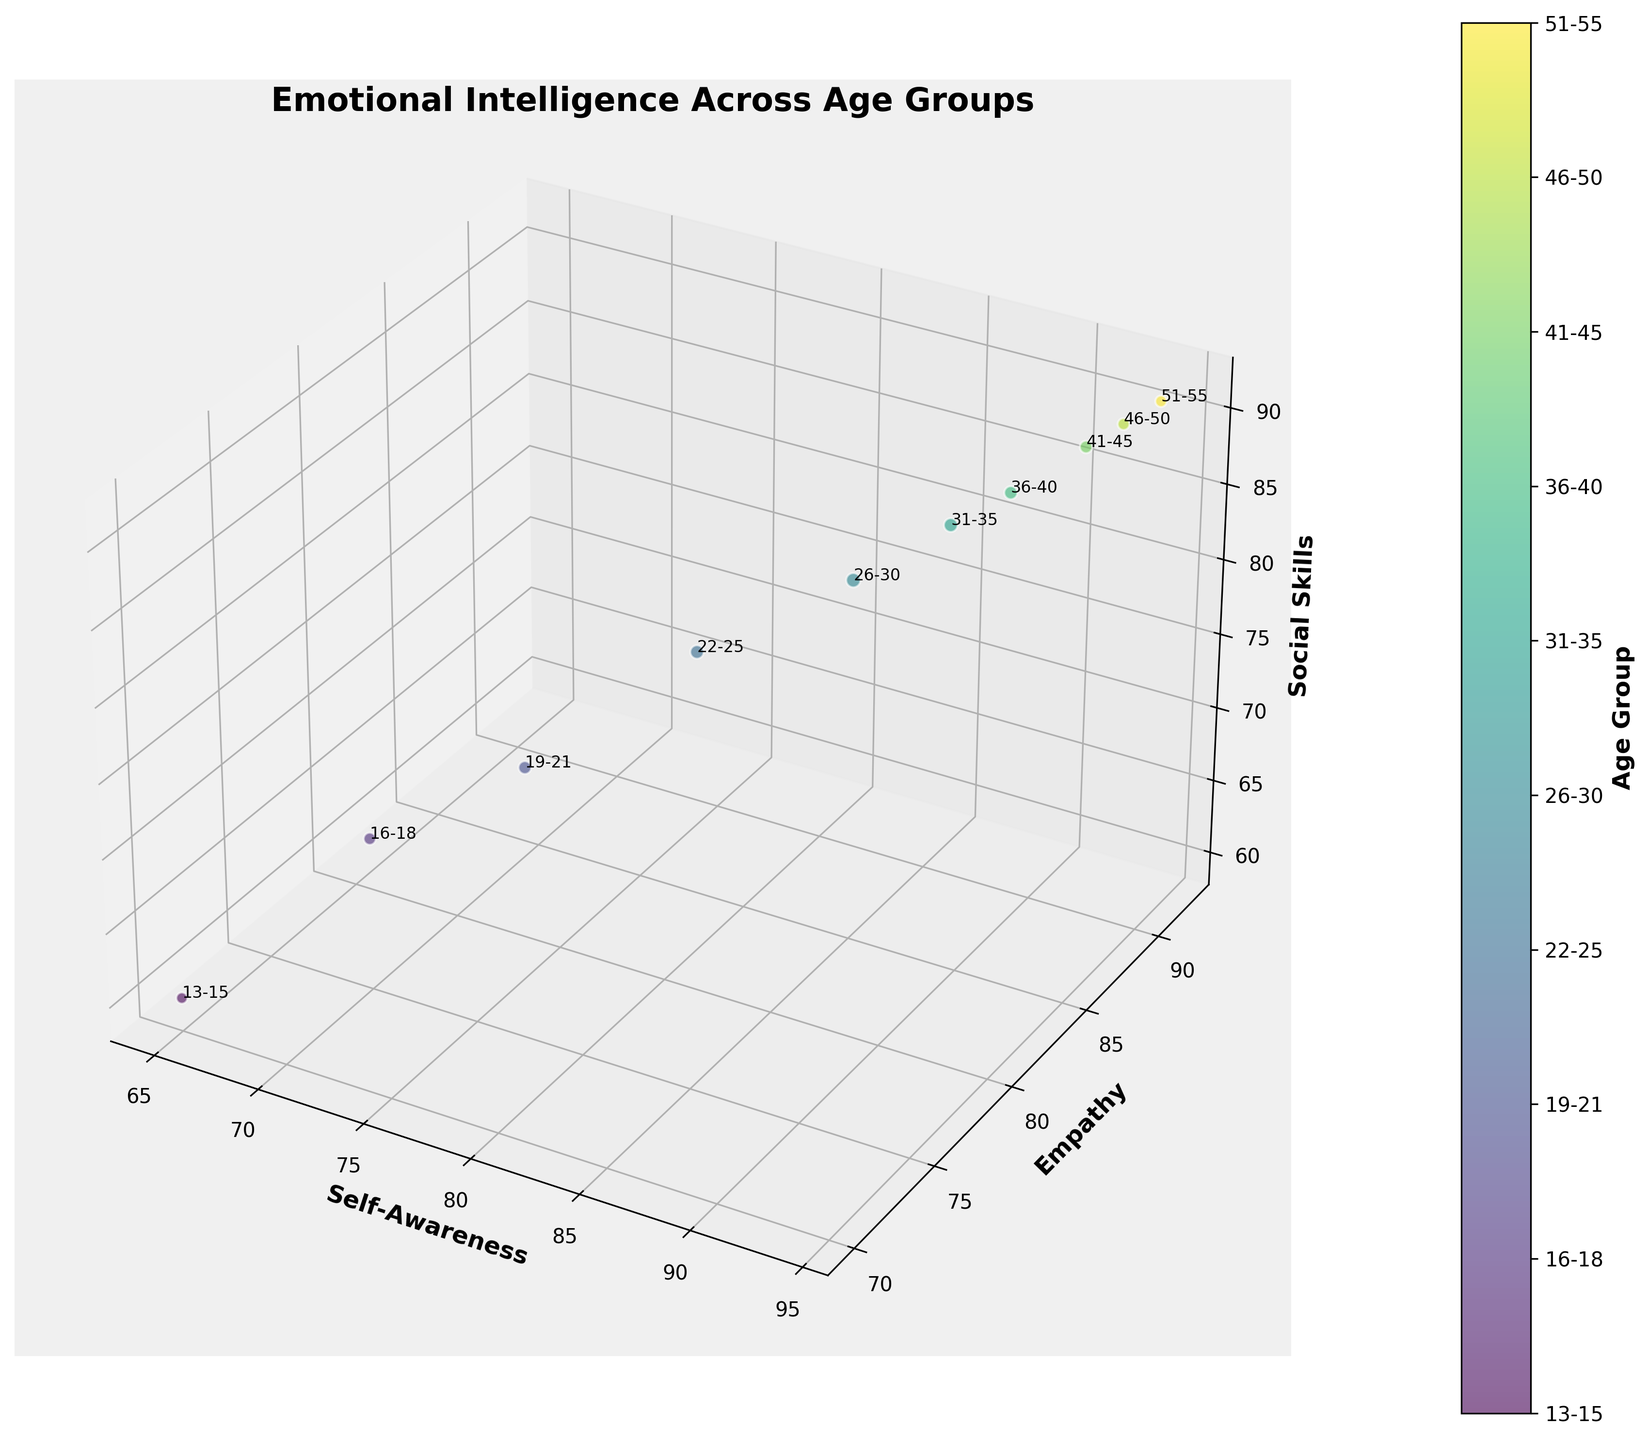what does the title of the figure indicate? The title of the figure is "Emotional Intelligence Across Age Groups". It suggests that the figure is about the variation of emotional intelligence metrics (self-awareness, empathy, and social skills) across different age groups.
Answer: Emotional Intelligence Across Age Groups How many age groups are there in the figure? By looking at the number of bubbles in the figure and the color bar labels, we can count the distinct age groups.
Answer: 10 What is the label on the x-axis? The label on the x-axis represents one of the emotional intelligence metrics being measured.
Answer: Self-Awareness Which age group has the largest bubble size? The size of the bubbles represents the sample size for each age group. The largest bubble is for the age group with the highest sample size.
Answer: 26-30 What is the average value of Self-Awareness for age groups 22-25 and 26-30? The self-awareness values for age groups 22-25 and 26-30 are 80 and 85, respectively. The average is calculated as (80 + 85) / 2.
Answer: 82.5 Does the empathy score generally increase or decrease with age? By observing the y-axis values for different age groups, we can see that the empathy score generally increases as the age group gets older.
Answer: Increase Which two age groups have the closest values in empathy? To find the closest empathy values, we need to compare the scores of all age groups and identify the two that are the most similar. Comparing all pairs, the closest values are those of age groups 41-45 and 46-50 (90 and 91).
Answer: 41-45 and 46-50 Does the 51-55 age group have higher, lower, or similar social skills scores compared to the 36-40 age group? By comparing the z-axis values for the age groups 51-55 and 36-40, we see 51-55 has a social skills score of 91 and 36-40 has 87, indicating a higher value for 51-55.
Answer: Higher How does the self-awareness of the 31-35 group compare to the 13-15 group? Looking at the x-axis values for 31-35 (88) and 13-15 (65), we can see that self-awareness is higher for the 31-35 group.
Answer: Higher What trend can be observed in the social skills scores from age group 19-21 to 51-55? Observing the z-axis values moving from the 19-21 group (72) to the 51-55 group (91), we see a general increasing trend in social skills.
Answer: Increasing 